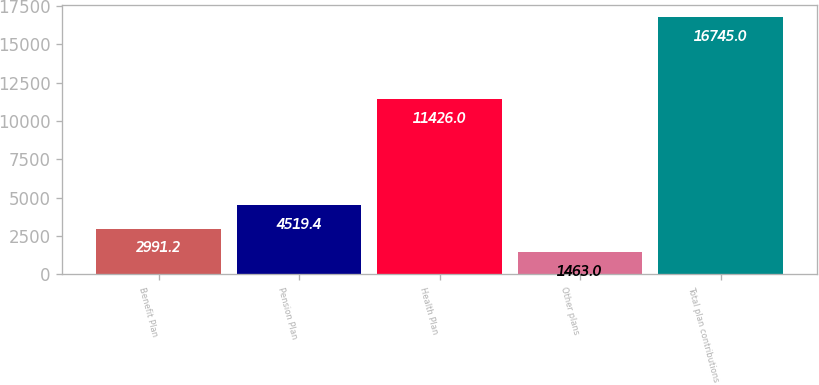Convert chart to OTSL. <chart><loc_0><loc_0><loc_500><loc_500><bar_chart><fcel>Benefit Plan<fcel>Pension Plan<fcel>Health Plan<fcel>Other plans<fcel>Total plan contributions<nl><fcel>2991.2<fcel>4519.4<fcel>11426<fcel>1463<fcel>16745<nl></chart> 